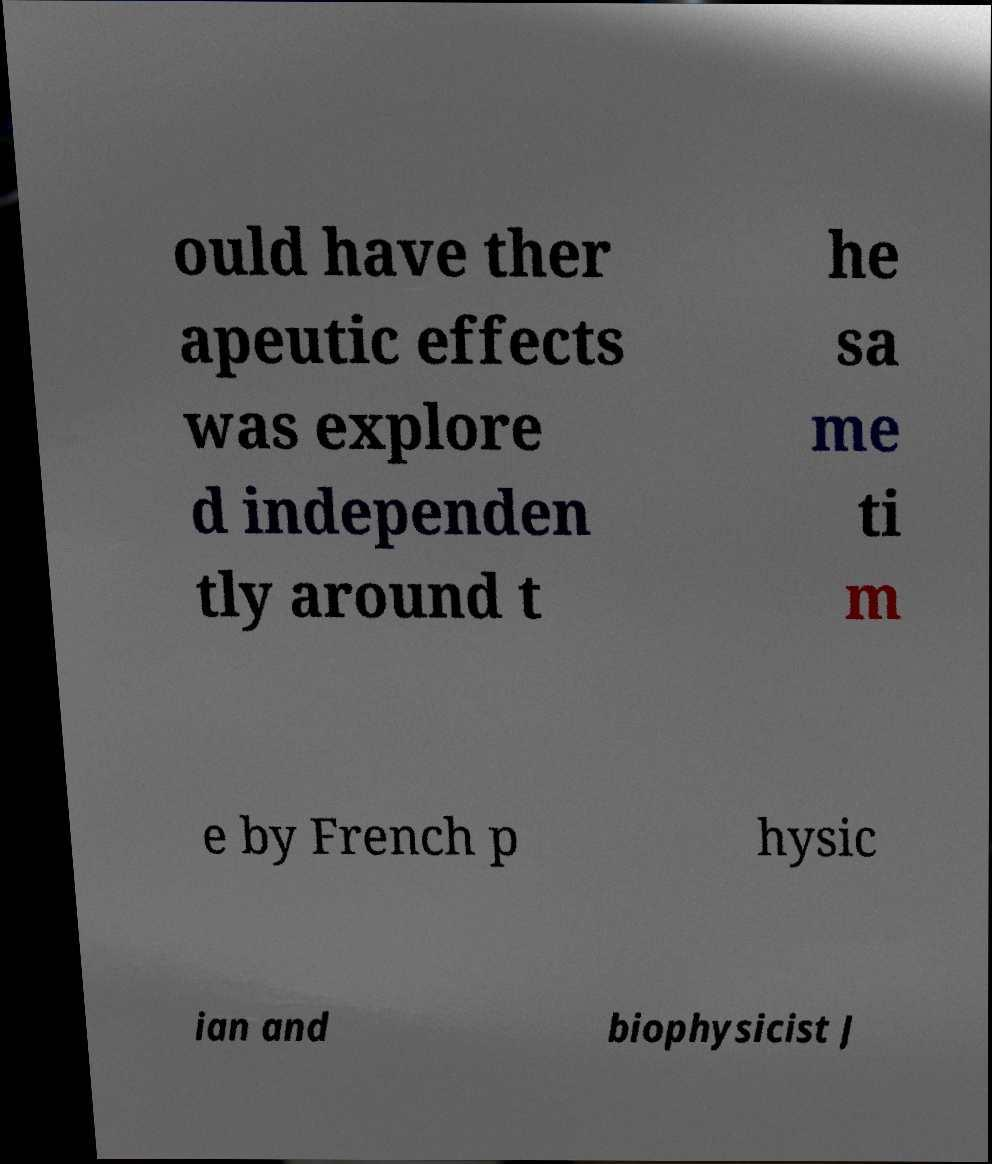Could you assist in decoding the text presented in this image and type it out clearly? ould have ther apeutic effects was explore d independen tly around t he sa me ti m e by French p hysic ian and biophysicist J 